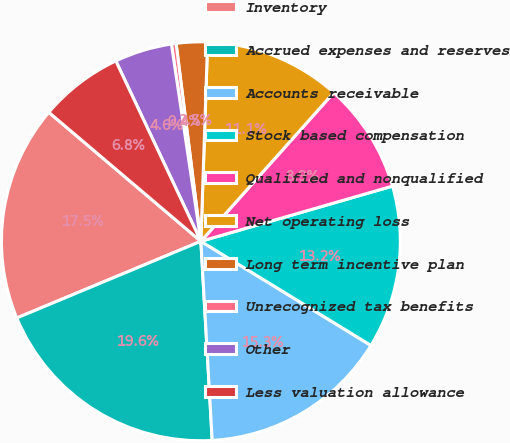<chart> <loc_0><loc_0><loc_500><loc_500><pie_chart><fcel>Inventory<fcel>Accrued expenses and reserves<fcel>Accounts receivable<fcel>Stock based compensation<fcel>Qualified and nonqualified<fcel>Net operating loss<fcel>Long term incentive plan<fcel>Unrecognized tax benefits<fcel>Other<fcel>Less valuation allowance<nl><fcel>17.48%<fcel>19.62%<fcel>15.35%<fcel>13.21%<fcel>8.93%<fcel>11.07%<fcel>2.52%<fcel>0.38%<fcel>4.65%<fcel>6.79%<nl></chart> 